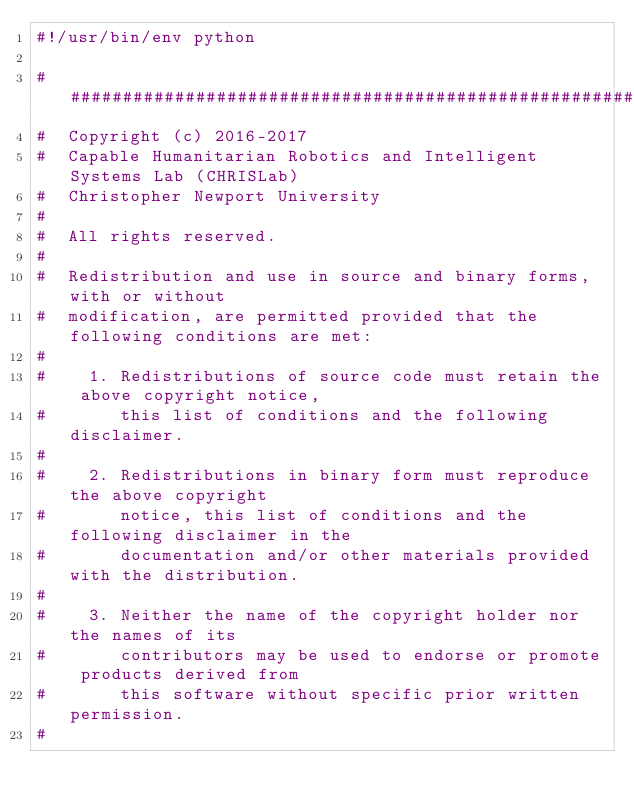<code> <loc_0><loc_0><loc_500><loc_500><_Python_>#!/usr/bin/env python

###############################################################################
#  Copyright (c) 2016-2017
#  Capable Humanitarian Robotics and Intelligent Systems Lab (CHRISLab)
#  Christopher Newport University
#
#  All rights reserved.
#
#  Redistribution and use in source and binary forms, with or without
#  modification, are permitted provided that the following conditions are met:
#
#    1. Redistributions of source code must retain the above copyright notice,
#       this list of conditions and the following disclaimer.
#
#    2. Redistributions in binary form must reproduce the above copyright
#       notice, this list of conditions and the following disclaimer in the
#       documentation and/or other materials provided with the distribution.
#
#    3. Neither the name of the copyright holder nor the names of its
#       contributors may be used to endorse or promote products derived from
#       this software without specific prior written permission.
#</code> 